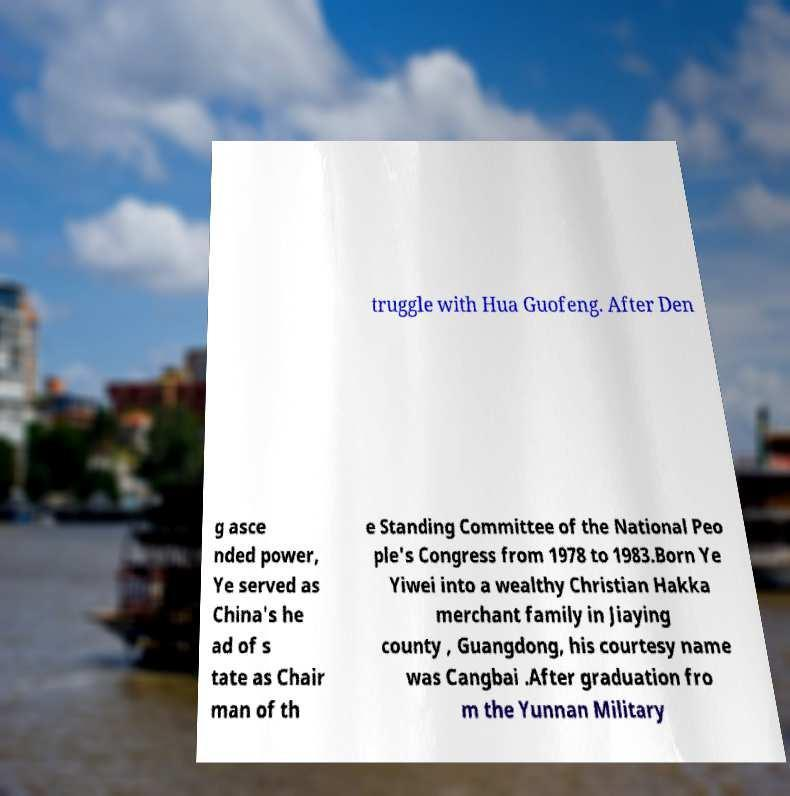Can you accurately transcribe the text from the provided image for me? truggle with Hua Guofeng. After Den g asce nded power, Ye served as China's he ad of s tate as Chair man of th e Standing Committee of the National Peo ple's Congress from 1978 to 1983.Born Ye Yiwei into a wealthy Christian Hakka merchant family in Jiaying county , Guangdong, his courtesy name was Cangbai .After graduation fro m the Yunnan Military 